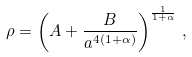<formula> <loc_0><loc_0><loc_500><loc_500>\rho = \left ( A + \frac { B } { a ^ { 4 ( 1 + \alpha ) } } \right ) ^ { \frac { 1 } { 1 + \alpha } } \, ,</formula> 